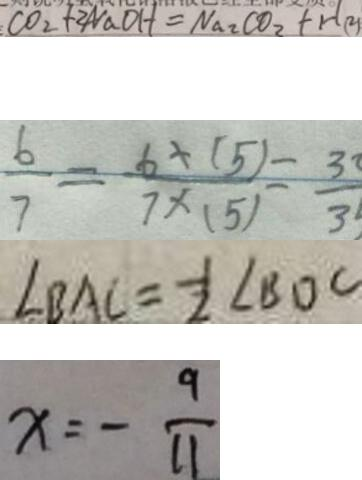Convert formula to latex. <formula><loc_0><loc_0><loc_500><loc_500>C O _ { 2 } + 2 N a O H = N a _ { 2 } C O _ { 2 } + H ( 2 ) 
 \frac { 6 } { 7 } = \frac { 6 \times ( 5 ) } { 7 \times ( 5 ) } - \frac { 3 } { 3 } 
 \angle B A C = \frac { 1 } { 2 } \angle B D C 
 x = - \frac { 9 } { 1 1 }</formula> 